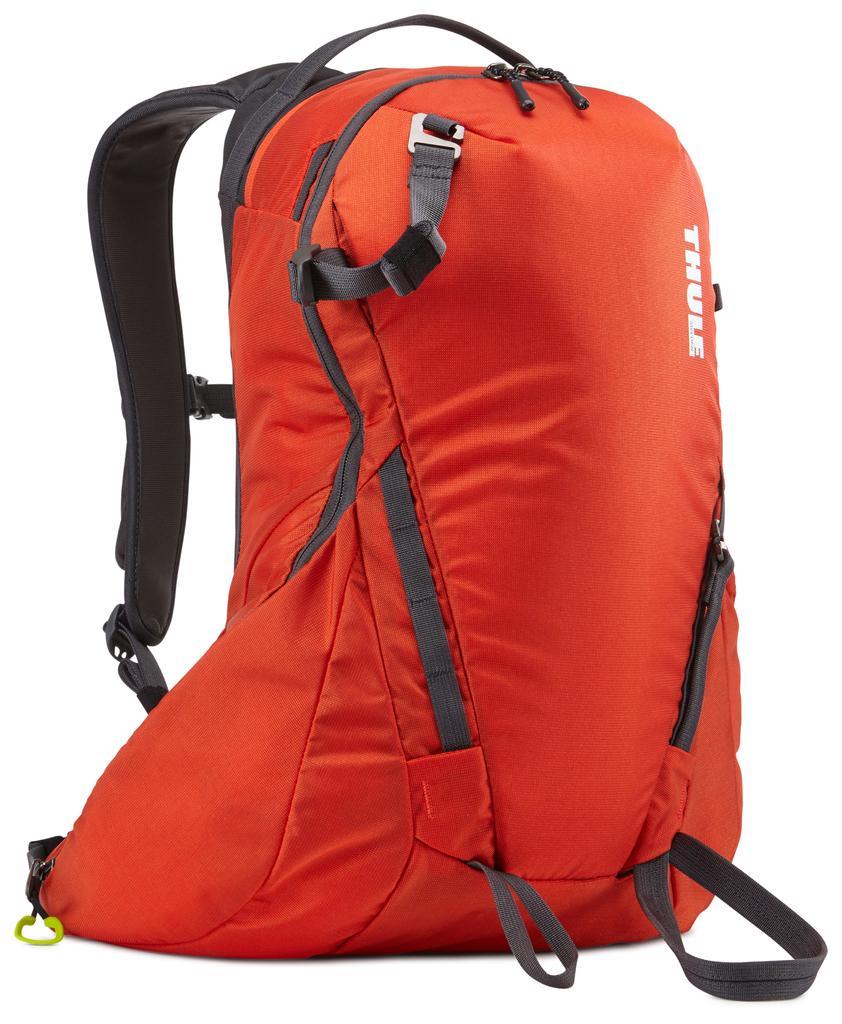How would you summarize this image in a sentence or two? This picture shows a travel bag which is orange in color. In the background there is white 